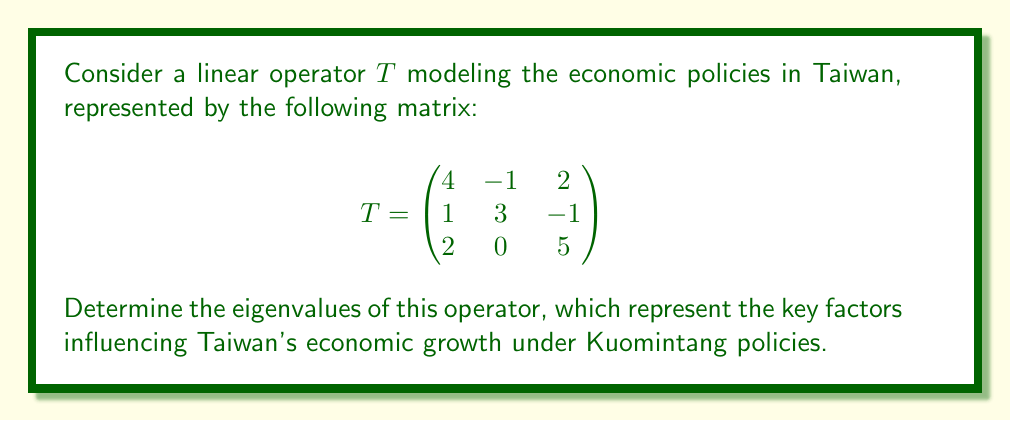Teach me how to tackle this problem. To find the eigenvalues of the linear operator $T$, we need to solve the characteristic equation:

$$\det(T - \lambda I) = 0$$

Where $I$ is the $3 \times 3$ identity matrix and $\lambda$ represents the eigenvalues.

Step 1: Set up the characteristic equation:

$$
\det\begin{pmatrix}
4-\lambda & -1 & 2 \\
1 & 3-\lambda & -1 \\
2 & 0 & 5-\lambda
\end{pmatrix} = 0
$$

Step 2: Expand the determinant:

$$(4-\lambda)[(3-\lambda)(5-\lambda) + 0] + (-1)[1(5-\lambda) + 2(-1)] + 2[1 \cdot 0 - 2(3-\lambda)] = 0$$

Step 3: Simplify:

$$(4-\lambda)(15-8\lambda+\lambda^2) + (-1)(5-\lambda-2) + 2(-6+2\lambda) = 0$$

$$60-32\lambda+4\lambda^2-15\lambda+8\lambda^2-\lambda^3 - 3 + \lambda - 12 + 4\lambda = 0$$

Step 4: Collect terms:

$$-\lambda^3 + 12\lambda^2 - 27\lambda + 45 = 0$$

Step 5: Factor the cubic equation:

$$-(\lambda - 3)(\lambda - 4)(\lambda - 5) = 0$$

Step 6: Solve for $\lambda$:

The eigenvalues are the roots of this equation: $\lambda = 3, 4, 5$
Answer: The eigenvalues of the linear operator $T$ are $\lambda_1 = 3$, $\lambda_2 = 4$, and $\lambda_3 = 5$. 